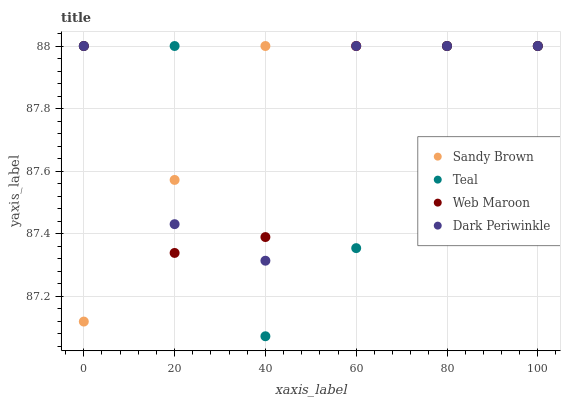Does Teal have the minimum area under the curve?
Answer yes or no. Yes. Does Sandy Brown have the maximum area under the curve?
Answer yes or no. Yes. Does Dark Periwinkle have the minimum area under the curve?
Answer yes or no. No. Does Dark Periwinkle have the maximum area under the curve?
Answer yes or no. No. Is Sandy Brown the smoothest?
Answer yes or no. Yes. Is Teal the roughest?
Answer yes or no. Yes. Is Dark Periwinkle the smoothest?
Answer yes or no. No. Is Dark Periwinkle the roughest?
Answer yes or no. No. Does Teal have the lowest value?
Answer yes or no. Yes. Does Sandy Brown have the lowest value?
Answer yes or no. No. Does Teal have the highest value?
Answer yes or no. Yes. Does Sandy Brown intersect Dark Periwinkle?
Answer yes or no. Yes. Is Sandy Brown less than Dark Periwinkle?
Answer yes or no. No. Is Sandy Brown greater than Dark Periwinkle?
Answer yes or no. No. 